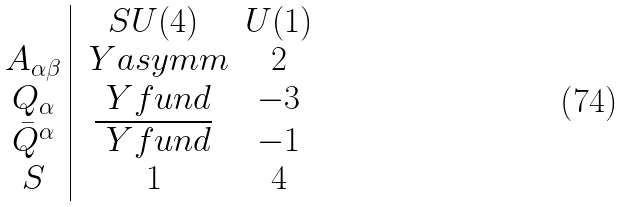Convert formula to latex. <formula><loc_0><loc_0><loc_500><loc_500>\begin{array} { c | c c } & S U ( 4 ) & U ( 1 ) \\ A _ { \alpha \beta } & \ Y a s y m m & 2 \\ Q _ { \alpha } & \ Y f u n d & - 3 \\ { \bar { Q } } ^ { \alpha } & \overline { \ Y f u n d } & - 1 \\ S & 1 & 4 \end{array}</formula> 